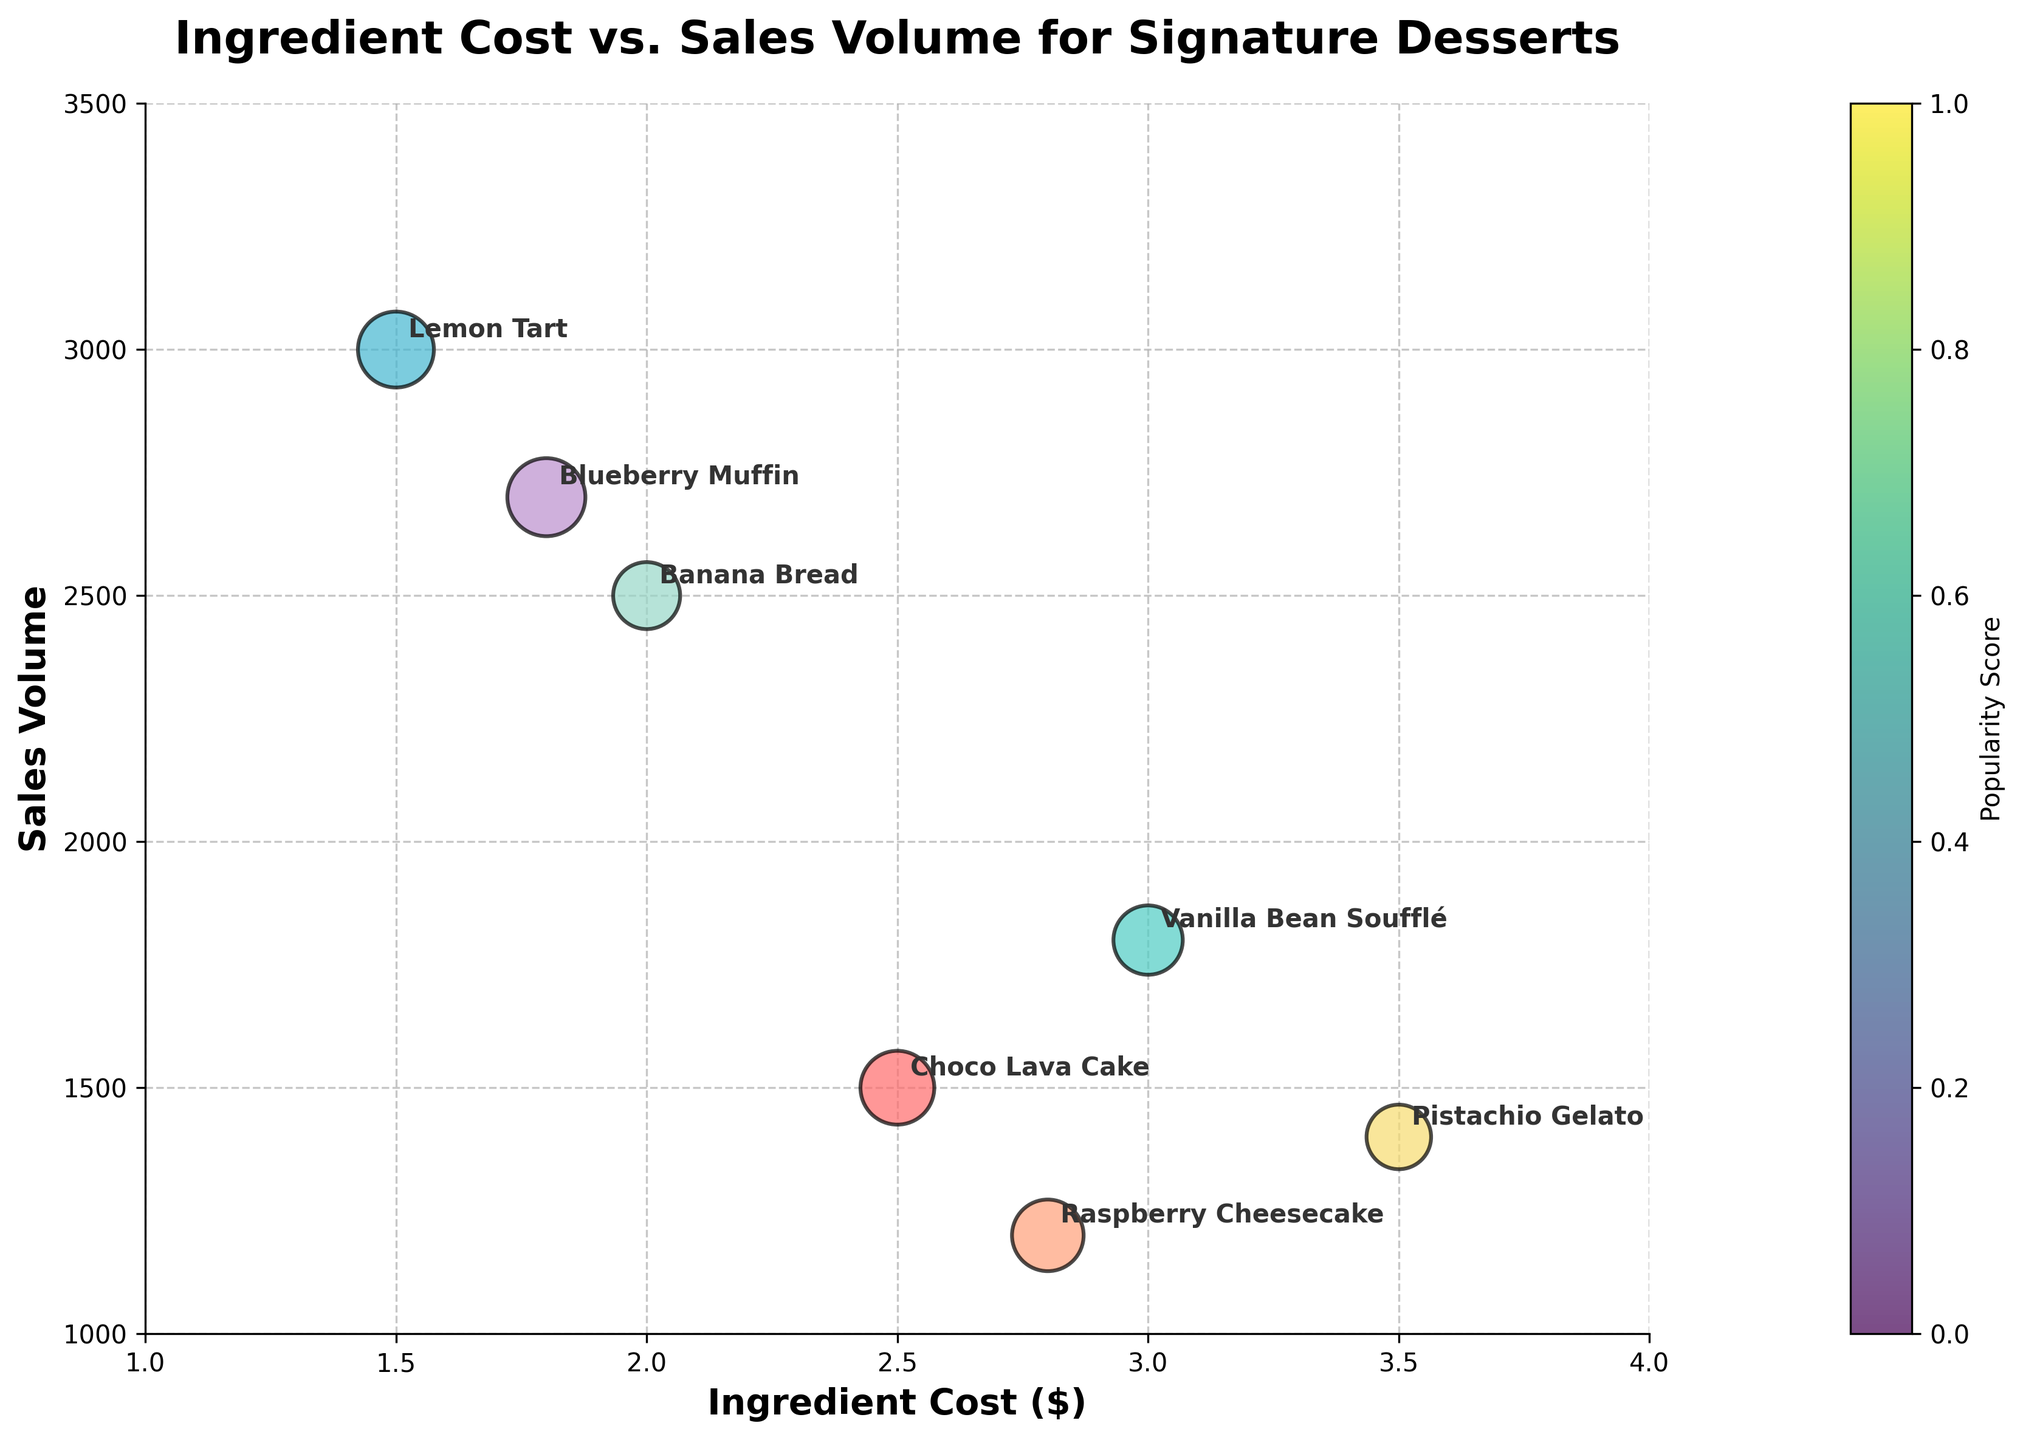What is the title of the chart? The title of the chart is typically located at the top and is usually the most prominent text. Here it reads "Ingredient Cost vs. Sales Volume for Signature Desserts".
Answer: Ingredient Cost vs. Sales Volume for Signature Desserts What does the x-axis represent? The x-axis is the horizontal axis and represents the variable "Ingredient Cost", which is marked with the label "Ingredient Cost ($)".
Answer: Ingredient Cost ($) How many products have an ingredient cost below $2.5? By visually inspecting the x-axis, identify the bubbles that lie to the left of the $2.5 mark. There are three such products: Lemon Tart, Banana Bread, and Blueberry Muffin.
Answer: 3 Which dessert has the highest sales volume? By observing the y-axis and identifying the highest point among all bubbles, the Lemon Tart has the highest sales volume of 3000.
Answer: Lemon Tart What color represents the "Choco Lava Cake"? By visually matching the colors of the bubbles to the chart, "Choco Lava Cake" is represented by a bubble with a light red color.
Answer: Light red Which dessert is the least popular based on the popularity score? Popularity is represented by bubble size, with smaller bubbles denoting lower popularity scores. The "Pistachio Gelato" has the smallest bubble size and thus the lowest popularity score of 65.
Answer: Pistachio Gelato What is the average ingredient cost of all the desserts? Sum the ingredient costs of all desserts (2.5 + 3.0 + 1.5 + 2.8 + 2.0 + 3.5 + 1.8) which equals 17.1, then divide by the number of desserts (7): (17.1/7).
Answer: 2.44 Compare the sales volume of "Vanilla Bean Soufflé" and "Banana Bread". Which one is higher? Locate both desserts on the chart and compare their respective positions on the y-axis. "Banana Bread" has a sales volume of 2500, which is higher than "Vanilla Bean Soufflé" with 1800.
Answer: Banana Bread How does the ingredient cost of "Blueberry Muffin" compare to "Choco Lava Cake"? Compare their positions on the x-axis. "Blueberry Muffin" has an ingredient cost of $1.8, while "Choco Lava Cake" has $2.5. Therefore, "Blueberry Muffin" is cheaper.
Answer: Blueberry Muffin Which dessert has the highest popularity score? Popularity is indicated by bubble size, where larger bubbles represent higher popularity. "Blueberry Muffin" has the largest bubble and thus the highest popularity score of 95.
Answer: Blueberry Muffin 